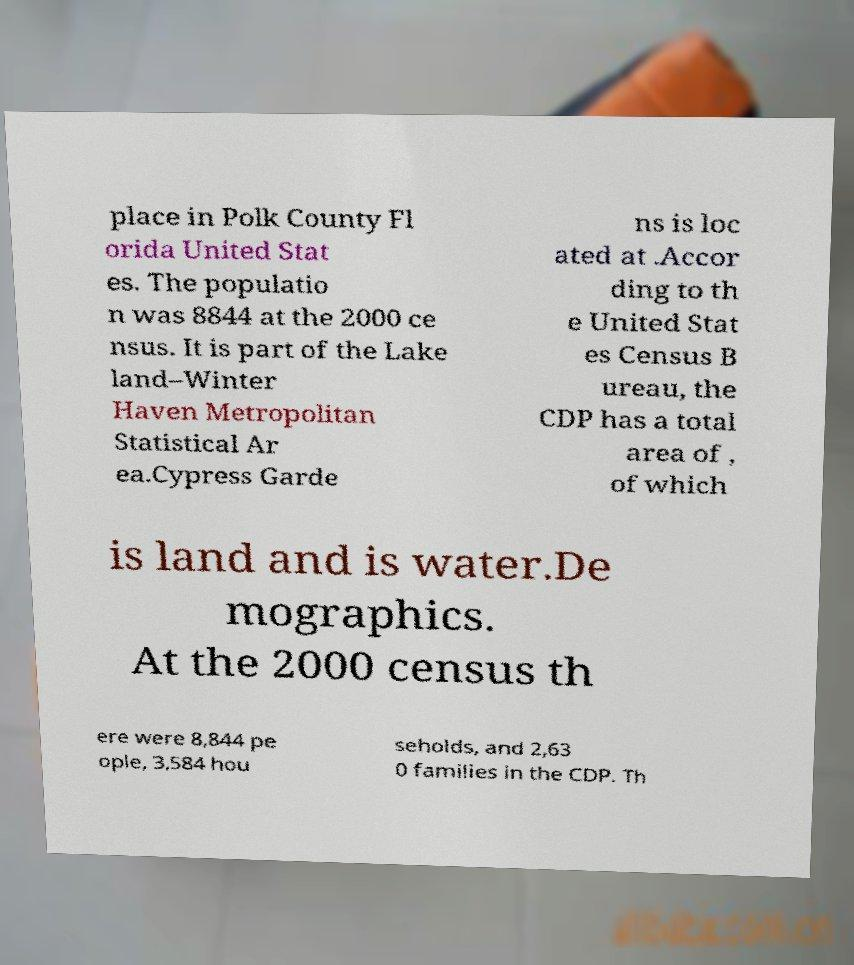Please read and relay the text visible in this image. What does it say? place in Polk County Fl orida United Stat es. The populatio n was 8844 at the 2000 ce nsus. It is part of the Lake land–Winter Haven Metropolitan Statistical Ar ea.Cypress Garde ns is loc ated at .Accor ding to th e United Stat es Census B ureau, the CDP has a total area of , of which is land and is water.De mographics. At the 2000 census th ere were 8,844 pe ople, 3,584 hou seholds, and 2,63 0 families in the CDP. Th 